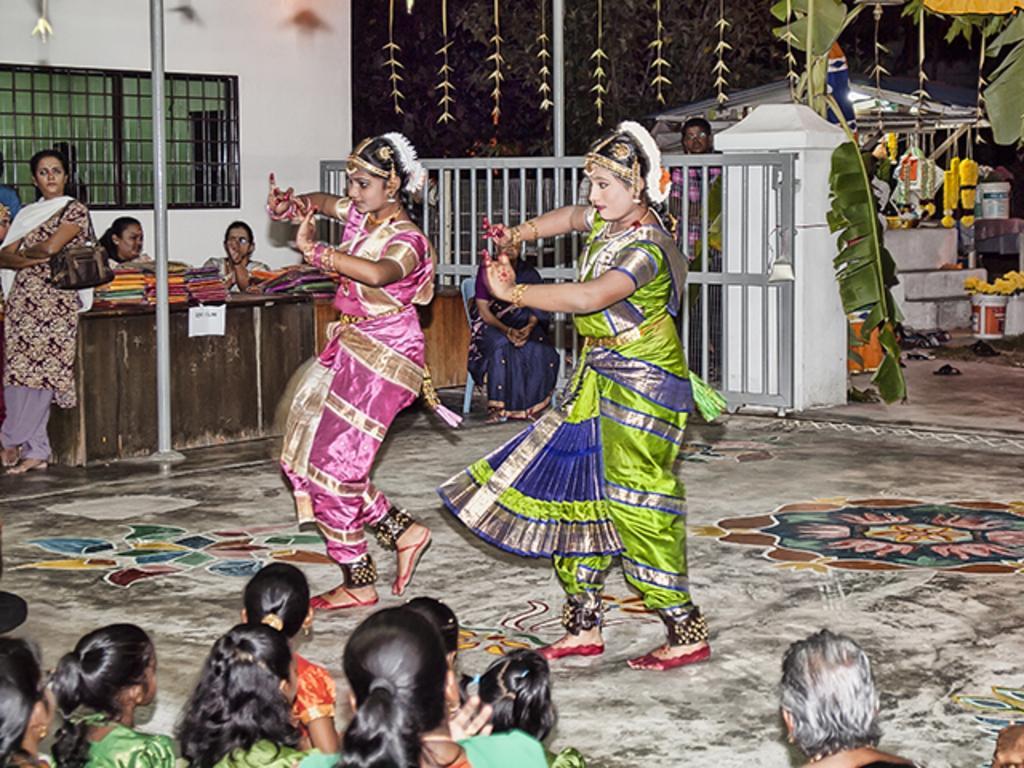In one or two sentences, can you explain what this image depicts? In the picture I can see two women dressed in a traditional manner and they are dancing on the floor. I can see a few people sitting on the ground and they are at the bottom of the picture. I can see the sarees on the wooden table. There is a woman on the left side and she is carrying a handbag. I can see a woman sitting on the chair. I can see the metal gate. I can see the trees, footwear and plastic buckets on the top right side. 